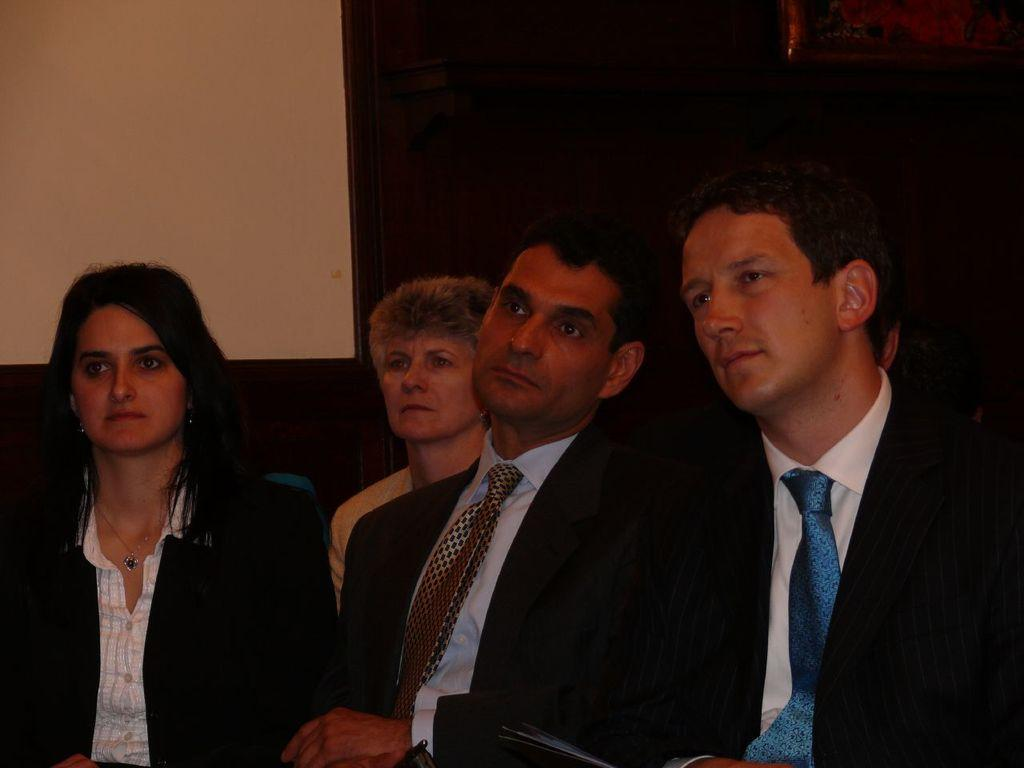How many people are sitting in the image? There are four people sitting on chairs in the image. What can be seen on the right side of the image? There is a wooden object visible on the right side of the image. What is in the background of the image? There is a wall in the background of the image. What type of spark can be seen on the wrist of one of the people in the image? There is no spark visible on anyone's wrist in the image. 